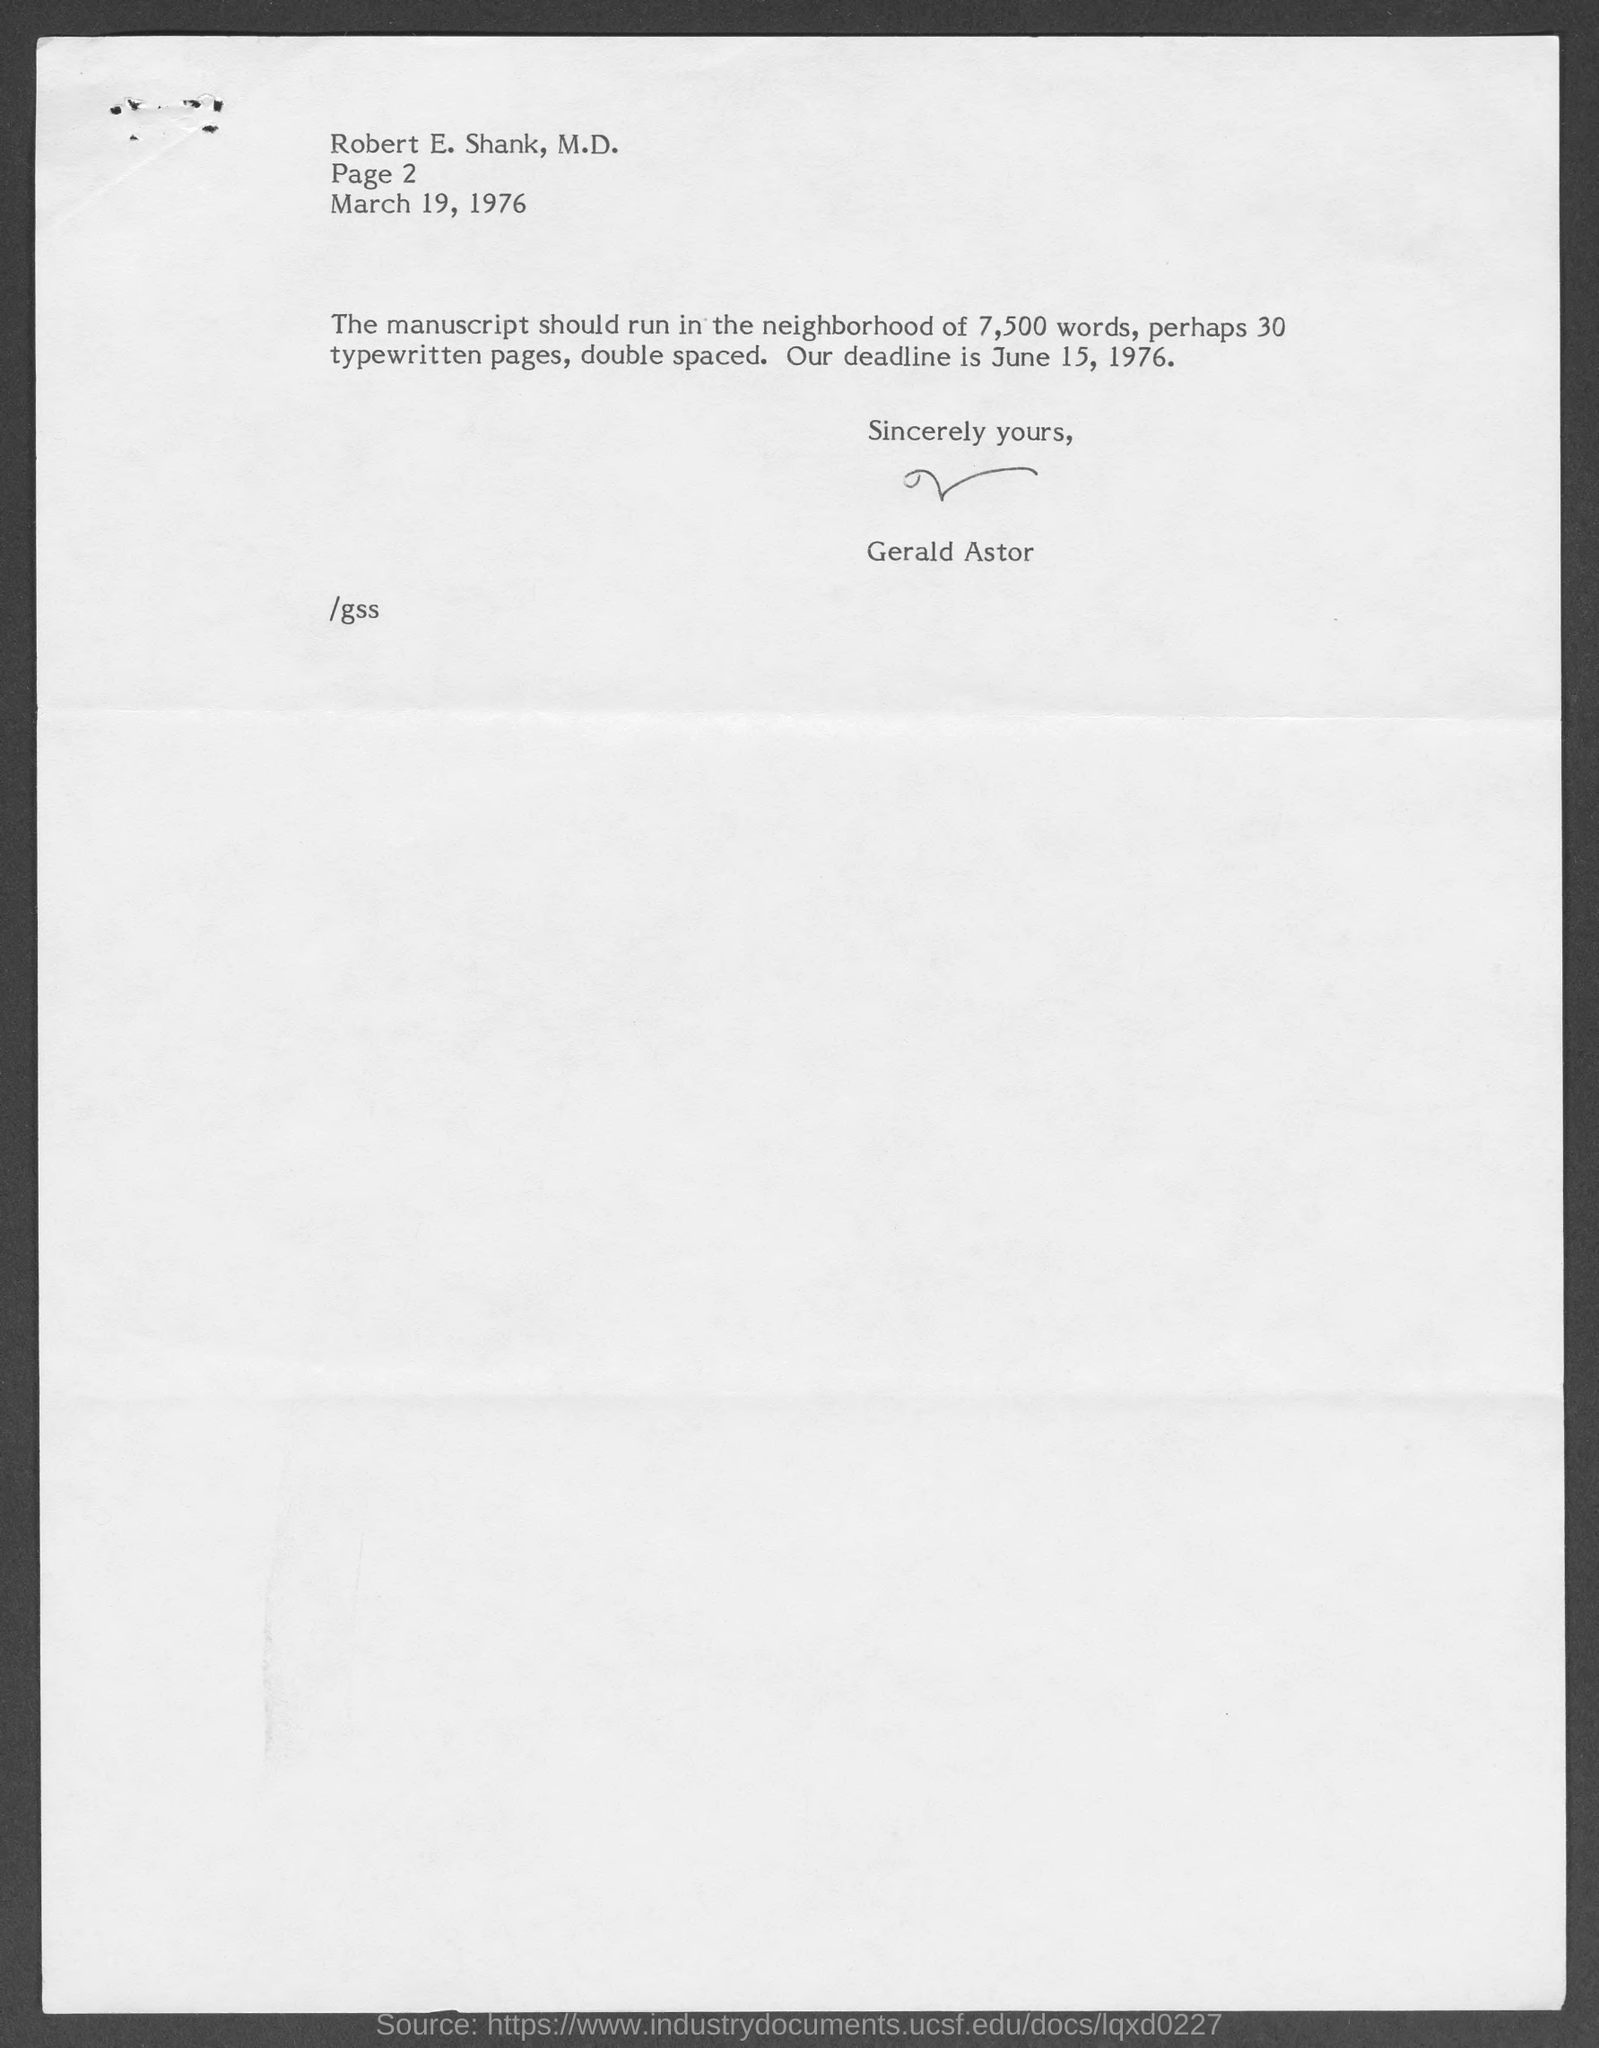Highlight a few significant elements in this photo. The date of the deadline mentioned in the given letter is June 15, 1976. March 19, 1976, is the date mentioned in the given letter. The speaker is informing the listener that at the end of the letter, there was a sign with the name "Gerald Astor" on it. It is recommended that the manuscript contain approximately 30 typewritten pages. 